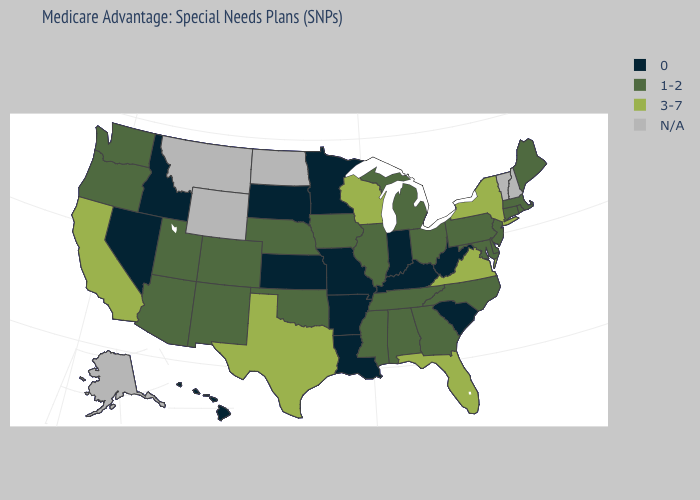Name the states that have a value in the range 1-2?
Write a very short answer. Alabama, Arizona, Colorado, Connecticut, Delaware, Georgia, Iowa, Illinois, Massachusetts, Maryland, Maine, Michigan, Mississippi, North Carolina, Nebraska, New Jersey, New Mexico, Ohio, Oklahoma, Oregon, Pennsylvania, Rhode Island, Tennessee, Utah, Washington. Name the states that have a value in the range 1-2?
Quick response, please. Alabama, Arizona, Colorado, Connecticut, Delaware, Georgia, Iowa, Illinois, Massachusetts, Maryland, Maine, Michigan, Mississippi, North Carolina, Nebraska, New Jersey, New Mexico, Ohio, Oklahoma, Oregon, Pennsylvania, Rhode Island, Tennessee, Utah, Washington. Among the states that border Delaware , which have the lowest value?
Answer briefly. Maryland, New Jersey, Pennsylvania. What is the highest value in the South ?
Answer briefly. 3-7. Does the first symbol in the legend represent the smallest category?
Keep it brief. Yes. Name the states that have a value in the range 1-2?
Give a very brief answer. Alabama, Arizona, Colorado, Connecticut, Delaware, Georgia, Iowa, Illinois, Massachusetts, Maryland, Maine, Michigan, Mississippi, North Carolina, Nebraska, New Jersey, New Mexico, Ohio, Oklahoma, Oregon, Pennsylvania, Rhode Island, Tennessee, Utah, Washington. Name the states that have a value in the range 1-2?
Keep it brief. Alabama, Arizona, Colorado, Connecticut, Delaware, Georgia, Iowa, Illinois, Massachusetts, Maryland, Maine, Michigan, Mississippi, North Carolina, Nebraska, New Jersey, New Mexico, Ohio, Oklahoma, Oregon, Pennsylvania, Rhode Island, Tennessee, Utah, Washington. What is the value of Texas?
Answer briefly. 3-7. Which states have the highest value in the USA?
Be succinct. California, Florida, New York, Texas, Virginia, Wisconsin. Name the states that have a value in the range 3-7?
Quick response, please. California, Florida, New York, Texas, Virginia, Wisconsin. Name the states that have a value in the range 0?
Keep it brief. Arkansas, Hawaii, Idaho, Indiana, Kansas, Kentucky, Louisiana, Minnesota, Missouri, Nevada, South Carolina, South Dakota, West Virginia. Name the states that have a value in the range 0?
Give a very brief answer. Arkansas, Hawaii, Idaho, Indiana, Kansas, Kentucky, Louisiana, Minnesota, Missouri, Nevada, South Carolina, South Dakota, West Virginia. Name the states that have a value in the range 3-7?
Short answer required. California, Florida, New York, Texas, Virginia, Wisconsin. 